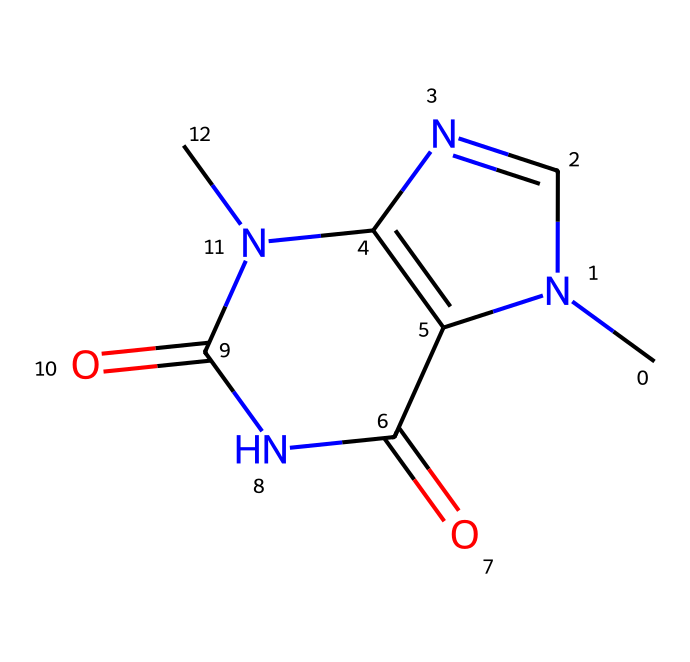What is the name of this chemical? The structure corresponds to the alkaloid found in cacao, known for its stimulating properties often associated with chocolate. The name derived from its chemical structure is theobromine.
Answer: theobromine How many nitrogen atoms are present in the molecule? By examining the SMILES representation, there are two explicit 'N' symbols, indicating the presence of two nitrogen atoms in the compound.
Answer: two What type of compound is this within organic chemistry? Analyzing the structure and functional groups visible in the molecular representation, specifically the nitrogen atoms and cyclic component, indicates that it is classified as an alkaloid.
Answer: alkaloid How many oxygen atoms are there in the structure? In the provided molecular structure, the presence of 'O' symbols, which occur twice, reveals that there are two oxygen atoms within this compound.
Answer: two What are the primary effects of this compound when consumed? The structural properties suggest it acts as a stimulant, primarily due to the presence of nitrogen in this particular alkaloid, and research shows it can enhance mood and alertness.
Answer: stimulant Which functional groups are present in theobromine? By analyzing the structure, we identify carbonyl functional groups (C=O) as well as the amine characteristics (N), which are integral to alkaloids like theobromine.
Answer: carbonyl and amine 